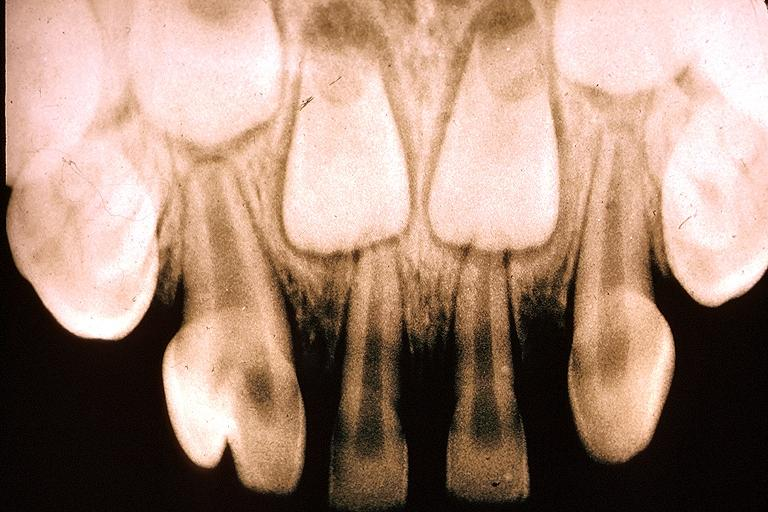does chronic lymphocytic leukemia show gemination?
Answer the question using a single word or phrase. No 